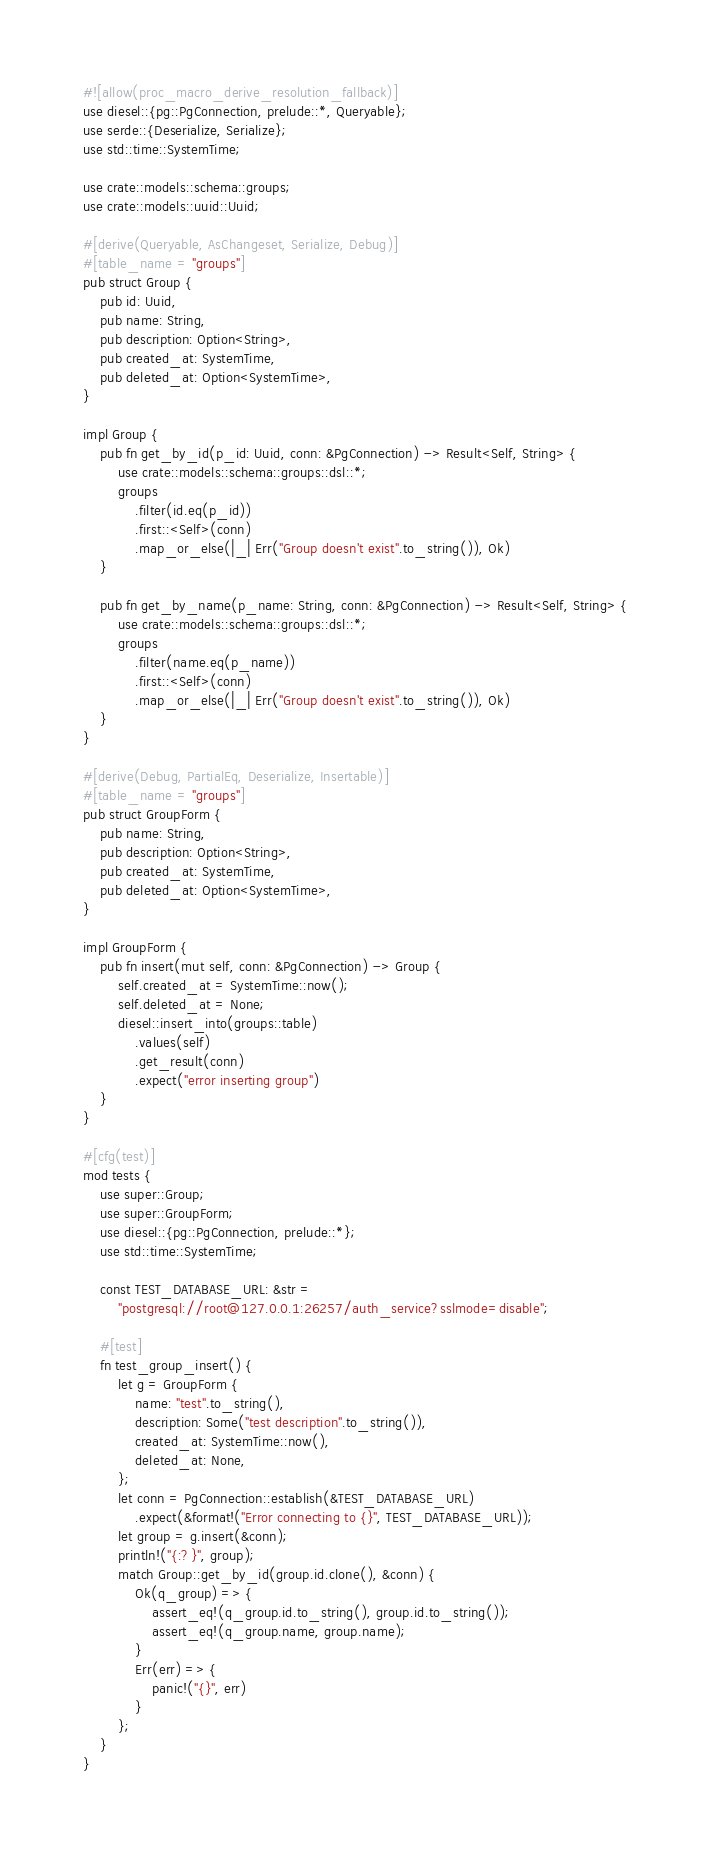Convert code to text. <code><loc_0><loc_0><loc_500><loc_500><_Rust_>#![allow(proc_macro_derive_resolution_fallback)]
use diesel::{pg::PgConnection, prelude::*, Queryable};
use serde::{Deserialize, Serialize};
use std::time::SystemTime;

use crate::models::schema::groups;
use crate::models::uuid::Uuid;

#[derive(Queryable, AsChangeset, Serialize, Debug)]
#[table_name = "groups"]
pub struct Group {
    pub id: Uuid,
    pub name: String,
    pub description: Option<String>,
    pub created_at: SystemTime,
    pub deleted_at: Option<SystemTime>,
}

impl Group {
    pub fn get_by_id(p_id: Uuid, conn: &PgConnection) -> Result<Self, String> {
        use crate::models::schema::groups::dsl::*;
        groups
            .filter(id.eq(p_id))
            .first::<Self>(conn)
            .map_or_else(|_| Err("Group doesn't exist".to_string()), Ok)
    }

    pub fn get_by_name(p_name: String, conn: &PgConnection) -> Result<Self, String> {
        use crate::models::schema::groups::dsl::*;
        groups
            .filter(name.eq(p_name))
            .first::<Self>(conn)
            .map_or_else(|_| Err("Group doesn't exist".to_string()), Ok)
    }
}

#[derive(Debug, PartialEq, Deserialize, Insertable)]
#[table_name = "groups"]
pub struct GroupForm {
    pub name: String,
    pub description: Option<String>,
    pub created_at: SystemTime,
    pub deleted_at: Option<SystemTime>,
}

impl GroupForm {
    pub fn insert(mut self, conn: &PgConnection) -> Group {
        self.created_at = SystemTime::now();
        self.deleted_at = None;
        diesel::insert_into(groups::table)
            .values(self)
            .get_result(conn)
            .expect("error inserting group")
    }
}

#[cfg(test)]
mod tests {
    use super::Group;
    use super::GroupForm;
    use diesel::{pg::PgConnection, prelude::*};
    use std::time::SystemTime;

    const TEST_DATABASE_URL: &str =
        "postgresql://root@127.0.0.1:26257/auth_service?sslmode=disable";

    #[test]
    fn test_group_insert() {
        let g = GroupForm {
            name: "test".to_string(),
            description: Some("test description".to_string()),
            created_at: SystemTime::now(),
            deleted_at: None,
        };
        let conn = PgConnection::establish(&TEST_DATABASE_URL)
            .expect(&format!("Error connecting to {}", TEST_DATABASE_URL));
        let group = g.insert(&conn);
        println!("{:?}", group);
        match Group::get_by_id(group.id.clone(), &conn) {
            Ok(q_group) => {
                assert_eq!(q_group.id.to_string(), group.id.to_string());
                assert_eq!(q_group.name, group.name);
            }
            Err(err) => {
                panic!("{}", err)
            }
        };
    }
}
</code> 